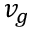Convert formula to latex. <formula><loc_0><loc_0><loc_500><loc_500>v _ { g }</formula> 